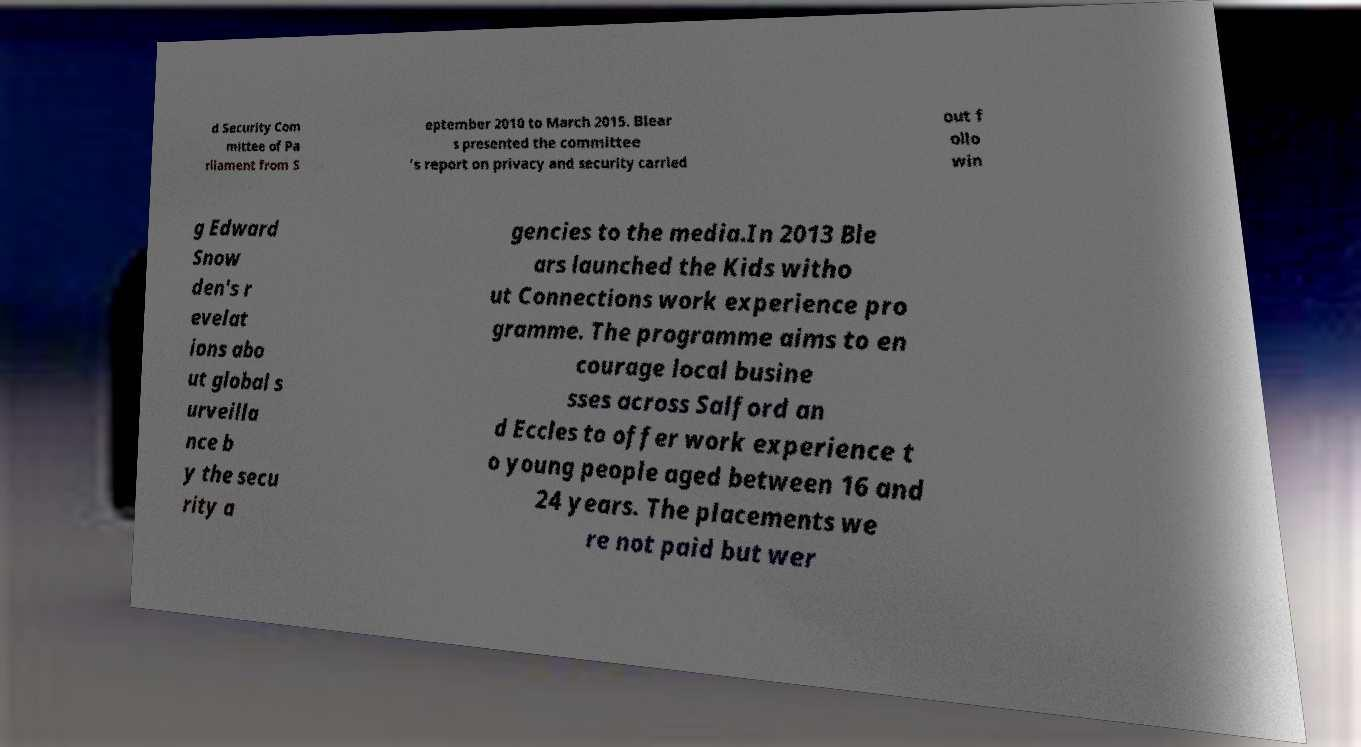Please identify and transcribe the text found in this image. d Security Com mittee of Pa rliament from S eptember 2010 to March 2015. Blear s presented the committee 's report on privacy and security carried out f ollo win g Edward Snow den's r evelat ions abo ut global s urveilla nce b y the secu rity a gencies to the media.In 2013 Ble ars launched the Kids witho ut Connections work experience pro gramme. The programme aims to en courage local busine sses across Salford an d Eccles to offer work experience t o young people aged between 16 and 24 years. The placements we re not paid but wer 